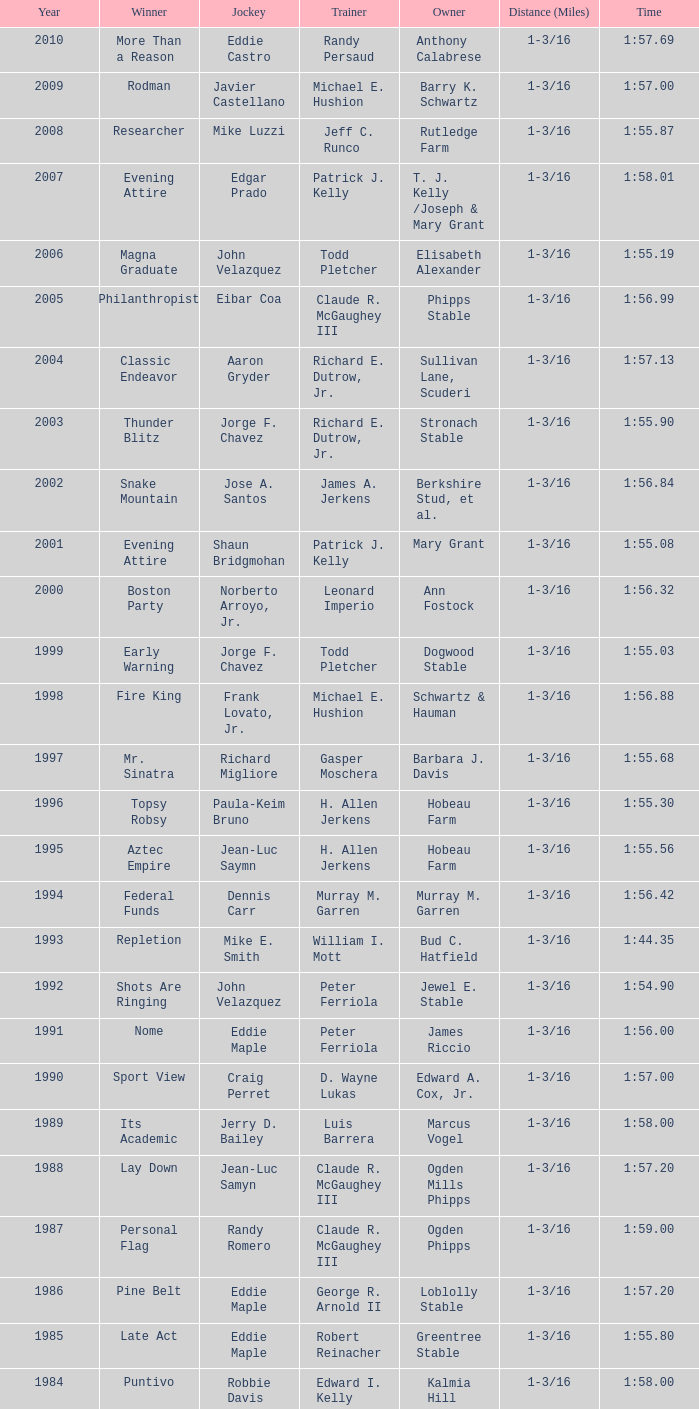What was the winning time for the winning horse, Kentucky ii? 1:38.80. 